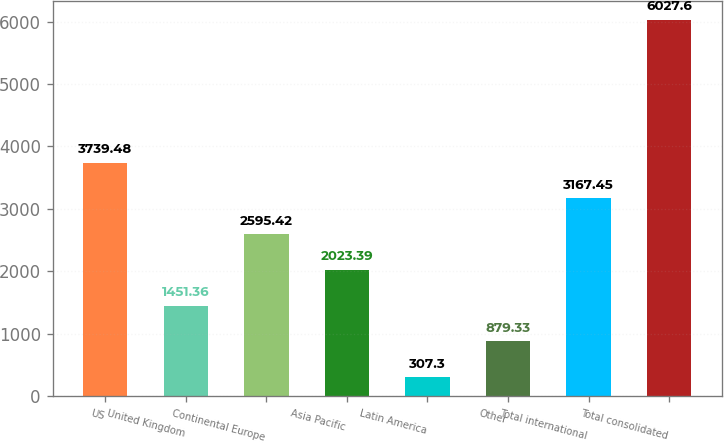<chart> <loc_0><loc_0><loc_500><loc_500><bar_chart><fcel>US<fcel>United Kingdom<fcel>Continental Europe<fcel>Asia Pacific<fcel>Latin America<fcel>Other<fcel>Total international<fcel>Total consolidated<nl><fcel>3739.48<fcel>1451.36<fcel>2595.42<fcel>2023.39<fcel>307.3<fcel>879.33<fcel>3167.45<fcel>6027.6<nl></chart> 